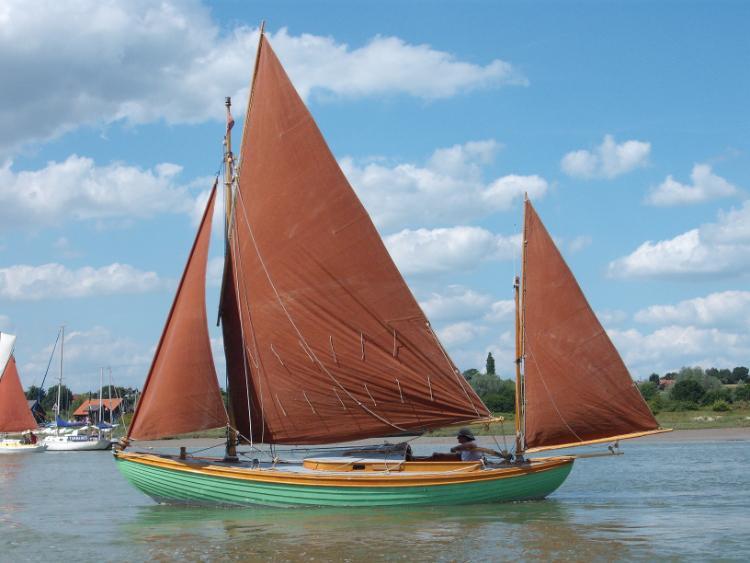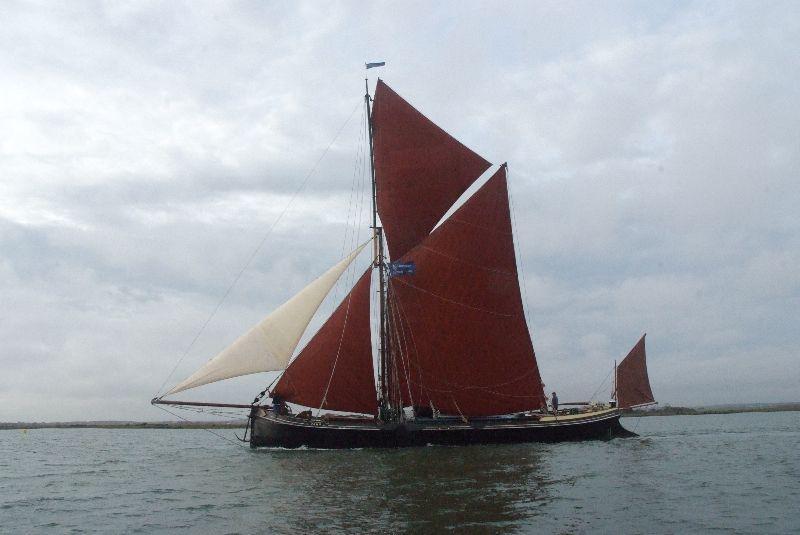The first image is the image on the left, the second image is the image on the right. Examine the images to the left and right. Is the description "In one image, at least one person is sailing on rough water in a white boat with at least two red sails, the largest one with two rows of thin vertical lines." accurate? Answer yes or no. No. The first image is the image on the left, the second image is the image on the right. Given the left and right images, does the statement "The body of the boat in the image on the right is white." hold true? Answer yes or no. No. 